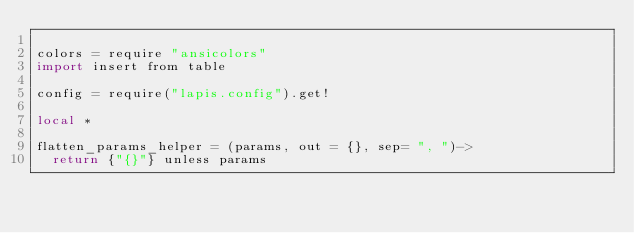Convert code to text. <code><loc_0><loc_0><loc_500><loc_500><_MoonScript_>
colors = require "ansicolors"
import insert from table

config = require("lapis.config").get!

local *

flatten_params_helper = (params, out = {}, sep= ", ")->
  return {"{}"} unless params
</code> 